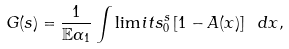Convert formula to latex. <formula><loc_0><loc_0><loc_500><loc_500>G ( s ) = \frac { 1 } { \mathbb { E } \alpha _ { 1 } } \int \lim i t s _ { 0 } ^ { s } \left [ 1 - A ( x ) \right ] \text { } d x ,</formula> 